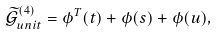<formula> <loc_0><loc_0><loc_500><loc_500>\mathcal { \widetilde { G } } _ { u n i t } ^ { ( 4 ) } = \phi ^ { T } ( t ) + \phi ( s ) + \phi ( u ) ,</formula> 